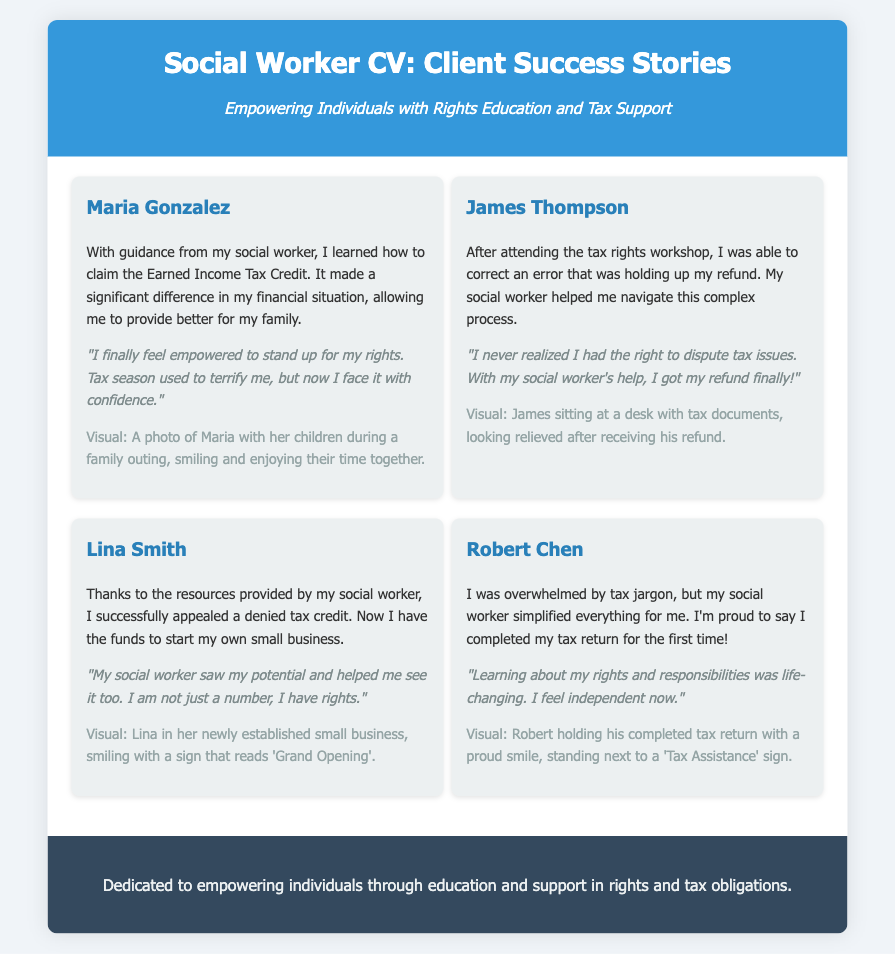What is the name of the first client featured? The first client mentioned in the document is Maria Gonzalez.
Answer: Maria Gonzalez What tax credit did Maria learn to claim? Maria learned to claim the Earned Income Tax Credit.
Answer: Earned Income Tax Credit What workshop did James attend? James attended the tax rights workshop.
Answer: tax rights workshop What action did Lina take with the help of her social worker? Lina successfully appealed a denied tax credit.
Answer: appealed a denied tax credit How did Robert feel after completing his tax return? Robert felt proud after completing his tax return for the first time.
Answer: proud What is depicted in the visual of Lina's story? Lina is in her newly established small business, smiling with a sign that reads 'Grand Opening'.
Answer: 'Grand Opening' sign What does Maria describe about her feelings toward tax season? Maria describes that tax season used to terrify her, but now she faces it with confidence.
Answer: terrified but now confident In whose story is the phrase "I never realized I had the right"? This phrase is in James Thompson's story.
Answer: James Thompson's story What is the overall theme of the document? The overall theme is empowering individuals with rights education and tax support.
Answer: empowering individuals 